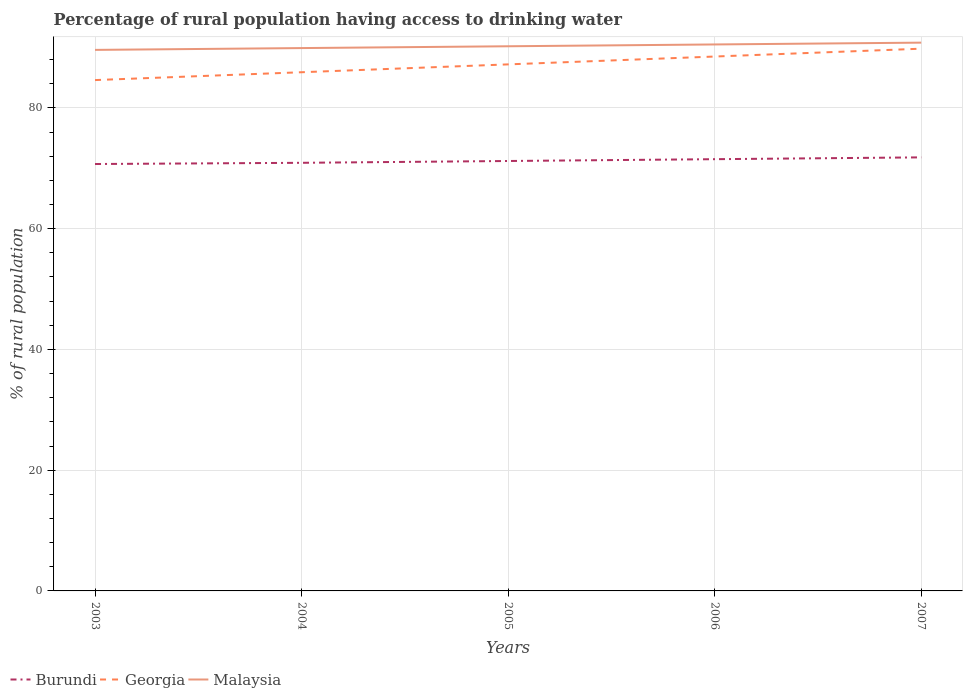How many different coloured lines are there?
Your response must be concise. 3. Does the line corresponding to Malaysia intersect with the line corresponding to Burundi?
Your response must be concise. No. Across all years, what is the maximum percentage of rural population having access to drinking water in Georgia?
Offer a terse response. 84.6. What is the total percentage of rural population having access to drinking water in Malaysia in the graph?
Your answer should be very brief. -0.9. What is the difference between the highest and the second highest percentage of rural population having access to drinking water in Malaysia?
Provide a short and direct response. 1.2. What is the difference between the highest and the lowest percentage of rural population having access to drinking water in Burundi?
Keep it short and to the point. 2. Is the percentage of rural population having access to drinking water in Burundi strictly greater than the percentage of rural population having access to drinking water in Georgia over the years?
Give a very brief answer. Yes. How many years are there in the graph?
Your answer should be very brief. 5. What is the difference between two consecutive major ticks on the Y-axis?
Offer a terse response. 20. Does the graph contain grids?
Provide a succinct answer. Yes. Where does the legend appear in the graph?
Provide a succinct answer. Bottom left. What is the title of the graph?
Make the answer very short. Percentage of rural population having access to drinking water. Does "Cote d'Ivoire" appear as one of the legend labels in the graph?
Ensure brevity in your answer.  No. What is the label or title of the Y-axis?
Make the answer very short. % of rural population. What is the % of rural population of Burundi in 2003?
Offer a terse response. 70.7. What is the % of rural population in Georgia in 2003?
Your answer should be very brief. 84.6. What is the % of rural population of Malaysia in 2003?
Make the answer very short. 89.6. What is the % of rural population of Burundi in 2004?
Keep it short and to the point. 70.9. What is the % of rural population of Georgia in 2004?
Keep it short and to the point. 85.9. What is the % of rural population in Malaysia in 2004?
Your answer should be compact. 89.9. What is the % of rural population of Burundi in 2005?
Your answer should be very brief. 71.2. What is the % of rural population in Georgia in 2005?
Ensure brevity in your answer.  87.2. What is the % of rural population of Malaysia in 2005?
Offer a terse response. 90.2. What is the % of rural population of Burundi in 2006?
Offer a terse response. 71.5. What is the % of rural population of Georgia in 2006?
Your answer should be compact. 88.5. What is the % of rural population in Malaysia in 2006?
Offer a terse response. 90.5. What is the % of rural population of Burundi in 2007?
Your answer should be very brief. 71.8. What is the % of rural population of Georgia in 2007?
Your response must be concise. 89.8. What is the % of rural population of Malaysia in 2007?
Your response must be concise. 90.8. Across all years, what is the maximum % of rural population of Burundi?
Your answer should be compact. 71.8. Across all years, what is the maximum % of rural population of Georgia?
Provide a short and direct response. 89.8. Across all years, what is the maximum % of rural population of Malaysia?
Provide a short and direct response. 90.8. Across all years, what is the minimum % of rural population in Burundi?
Provide a succinct answer. 70.7. Across all years, what is the minimum % of rural population in Georgia?
Offer a terse response. 84.6. Across all years, what is the minimum % of rural population of Malaysia?
Your answer should be compact. 89.6. What is the total % of rural population of Burundi in the graph?
Keep it short and to the point. 356.1. What is the total % of rural population in Georgia in the graph?
Your response must be concise. 436. What is the total % of rural population in Malaysia in the graph?
Provide a short and direct response. 451. What is the difference between the % of rural population in Malaysia in 2003 and that in 2004?
Keep it short and to the point. -0.3. What is the difference between the % of rural population of Burundi in 2003 and that in 2005?
Your answer should be very brief. -0.5. What is the difference between the % of rural population of Georgia in 2003 and that in 2005?
Give a very brief answer. -2.6. What is the difference between the % of rural population of Malaysia in 2003 and that in 2005?
Give a very brief answer. -0.6. What is the difference between the % of rural population of Georgia in 2003 and that in 2007?
Keep it short and to the point. -5.2. What is the difference between the % of rural population of Malaysia in 2004 and that in 2006?
Provide a short and direct response. -0.6. What is the difference between the % of rural population in Georgia in 2004 and that in 2007?
Provide a succinct answer. -3.9. What is the difference between the % of rural population of Malaysia in 2004 and that in 2007?
Keep it short and to the point. -0.9. What is the difference between the % of rural population in Malaysia in 2005 and that in 2006?
Provide a succinct answer. -0.3. What is the difference between the % of rural population in Burundi in 2005 and that in 2007?
Offer a very short reply. -0.6. What is the difference between the % of rural population in Burundi in 2006 and that in 2007?
Offer a terse response. -0.3. What is the difference between the % of rural population of Georgia in 2006 and that in 2007?
Ensure brevity in your answer.  -1.3. What is the difference between the % of rural population of Burundi in 2003 and the % of rural population of Georgia in 2004?
Give a very brief answer. -15.2. What is the difference between the % of rural population of Burundi in 2003 and the % of rural population of Malaysia in 2004?
Provide a short and direct response. -19.2. What is the difference between the % of rural population of Burundi in 2003 and the % of rural population of Georgia in 2005?
Provide a succinct answer. -16.5. What is the difference between the % of rural population in Burundi in 2003 and the % of rural population in Malaysia in 2005?
Your answer should be very brief. -19.5. What is the difference between the % of rural population in Georgia in 2003 and the % of rural population in Malaysia in 2005?
Your response must be concise. -5.6. What is the difference between the % of rural population in Burundi in 2003 and the % of rural population in Georgia in 2006?
Provide a succinct answer. -17.8. What is the difference between the % of rural population in Burundi in 2003 and the % of rural population in Malaysia in 2006?
Make the answer very short. -19.8. What is the difference between the % of rural population of Georgia in 2003 and the % of rural population of Malaysia in 2006?
Ensure brevity in your answer.  -5.9. What is the difference between the % of rural population of Burundi in 2003 and the % of rural population of Georgia in 2007?
Ensure brevity in your answer.  -19.1. What is the difference between the % of rural population in Burundi in 2003 and the % of rural population in Malaysia in 2007?
Give a very brief answer. -20.1. What is the difference between the % of rural population in Georgia in 2003 and the % of rural population in Malaysia in 2007?
Your answer should be very brief. -6.2. What is the difference between the % of rural population in Burundi in 2004 and the % of rural population in Georgia in 2005?
Offer a terse response. -16.3. What is the difference between the % of rural population of Burundi in 2004 and the % of rural population of Malaysia in 2005?
Make the answer very short. -19.3. What is the difference between the % of rural population in Burundi in 2004 and the % of rural population in Georgia in 2006?
Ensure brevity in your answer.  -17.6. What is the difference between the % of rural population in Burundi in 2004 and the % of rural population in Malaysia in 2006?
Provide a short and direct response. -19.6. What is the difference between the % of rural population in Georgia in 2004 and the % of rural population in Malaysia in 2006?
Provide a succinct answer. -4.6. What is the difference between the % of rural population of Burundi in 2004 and the % of rural population of Georgia in 2007?
Make the answer very short. -18.9. What is the difference between the % of rural population in Burundi in 2004 and the % of rural population in Malaysia in 2007?
Make the answer very short. -19.9. What is the difference between the % of rural population in Burundi in 2005 and the % of rural population in Georgia in 2006?
Make the answer very short. -17.3. What is the difference between the % of rural population in Burundi in 2005 and the % of rural population in Malaysia in 2006?
Ensure brevity in your answer.  -19.3. What is the difference between the % of rural population of Burundi in 2005 and the % of rural population of Georgia in 2007?
Give a very brief answer. -18.6. What is the difference between the % of rural population of Burundi in 2005 and the % of rural population of Malaysia in 2007?
Provide a short and direct response. -19.6. What is the difference between the % of rural population of Burundi in 2006 and the % of rural population of Georgia in 2007?
Offer a very short reply. -18.3. What is the difference between the % of rural population of Burundi in 2006 and the % of rural population of Malaysia in 2007?
Provide a succinct answer. -19.3. What is the difference between the % of rural population of Georgia in 2006 and the % of rural population of Malaysia in 2007?
Offer a very short reply. -2.3. What is the average % of rural population in Burundi per year?
Provide a short and direct response. 71.22. What is the average % of rural population of Georgia per year?
Ensure brevity in your answer.  87.2. What is the average % of rural population in Malaysia per year?
Give a very brief answer. 90.2. In the year 2003, what is the difference between the % of rural population in Burundi and % of rural population in Georgia?
Give a very brief answer. -13.9. In the year 2003, what is the difference between the % of rural population of Burundi and % of rural population of Malaysia?
Provide a succinct answer. -18.9. In the year 2003, what is the difference between the % of rural population in Georgia and % of rural population in Malaysia?
Your response must be concise. -5. In the year 2004, what is the difference between the % of rural population in Burundi and % of rural population in Malaysia?
Keep it short and to the point. -19. In the year 2004, what is the difference between the % of rural population of Georgia and % of rural population of Malaysia?
Provide a succinct answer. -4. In the year 2005, what is the difference between the % of rural population in Burundi and % of rural population in Georgia?
Offer a very short reply. -16. In the year 2005, what is the difference between the % of rural population of Georgia and % of rural population of Malaysia?
Keep it short and to the point. -3. In the year 2006, what is the difference between the % of rural population of Burundi and % of rural population of Georgia?
Provide a succinct answer. -17. In the year 2006, what is the difference between the % of rural population in Burundi and % of rural population in Malaysia?
Offer a terse response. -19. In the year 2007, what is the difference between the % of rural population of Burundi and % of rural population of Georgia?
Provide a succinct answer. -18. In the year 2007, what is the difference between the % of rural population in Georgia and % of rural population in Malaysia?
Provide a short and direct response. -1. What is the ratio of the % of rural population in Burundi in 2003 to that in 2004?
Keep it short and to the point. 1. What is the ratio of the % of rural population in Georgia in 2003 to that in 2004?
Keep it short and to the point. 0.98. What is the ratio of the % of rural population of Malaysia in 2003 to that in 2004?
Give a very brief answer. 1. What is the ratio of the % of rural population of Georgia in 2003 to that in 2005?
Your response must be concise. 0.97. What is the ratio of the % of rural population in Malaysia in 2003 to that in 2005?
Give a very brief answer. 0.99. What is the ratio of the % of rural population in Georgia in 2003 to that in 2006?
Your answer should be compact. 0.96. What is the ratio of the % of rural population of Malaysia in 2003 to that in 2006?
Make the answer very short. 0.99. What is the ratio of the % of rural population in Burundi in 2003 to that in 2007?
Keep it short and to the point. 0.98. What is the ratio of the % of rural population in Georgia in 2003 to that in 2007?
Your response must be concise. 0.94. What is the ratio of the % of rural population of Malaysia in 2003 to that in 2007?
Keep it short and to the point. 0.99. What is the ratio of the % of rural population of Georgia in 2004 to that in 2005?
Provide a short and direct response. 0.99. What is the ratio of the % of rural population in Malaysia in 2004 to that in 2005?
Make the answer very short. 1. What is the ratio of the % of rural population in Burundi in 2004 to that in 2006?
Offer a very short reply. 0.99. What is the ratio of the % of rural population of Georgia in 2004 to that in 2006?
Your response must be concise. 0.97. What is the ratio of the % of rural population of Burundi in 2004 to that in 2007?
Your response must be concise. 0.99. What is the ratio of the % of rural population of Georgia in 2004 to that in 2007?
Offer a terse response. 0.96. What is the ratio of the % of rural population in Malaysia in 2004 to that in 2007?
Give a very brief answer. 0.99. What is the ratio of the % of rural population in Burundi in 2005 to that in 2006?
Your answer should be compact. 1. What is the ratio of the % of rural population of Georgia in 2005 to that in 2006?
Your response must be concise. 0.99. What is the ratio of the % of rural population of Burundi in 2005 to that in 2007?
Give a very brief answer. 0.99. What is the ratio of the % of rural population of Georgia in 2005 to that in 2007?
Ensure brevity in your answer.  0.97. What is the ratio of the % of rural population in Malaysia in 2005 to that in 2007?
Make the answer very short. 0.99. What is the ratio of the % of rural population in Burundi in 2006 to that in 2007?
Give a very brief answer. 1. What is the ratio of the % of rural population of Georgia in 2006 to that in 2007?
Your answer should be compact. 0.99. What is the ratio of the % of rural population of Malaysia in 2006 to that in 2007?
Make the answer very short. 1. What is the difference between the highest and the second highest % of rural population of Georgia?
Offer a very short reply. 1.3. What is the difference between the highest and the second highest % of rural population in Malaysia?
Make the answer very short. 0.3. What is the difference between the highest and the lowest % of rural population in Burundi?
Provide a short and direct response. 1.1. What is the difference between the highest and the lowest % of rural population of Georgia?
Keep it short and to the point. 5.2. What is the difference between the highest and the lowest % of rural population of Malaysia?
Your response must be concise. 1.2. 